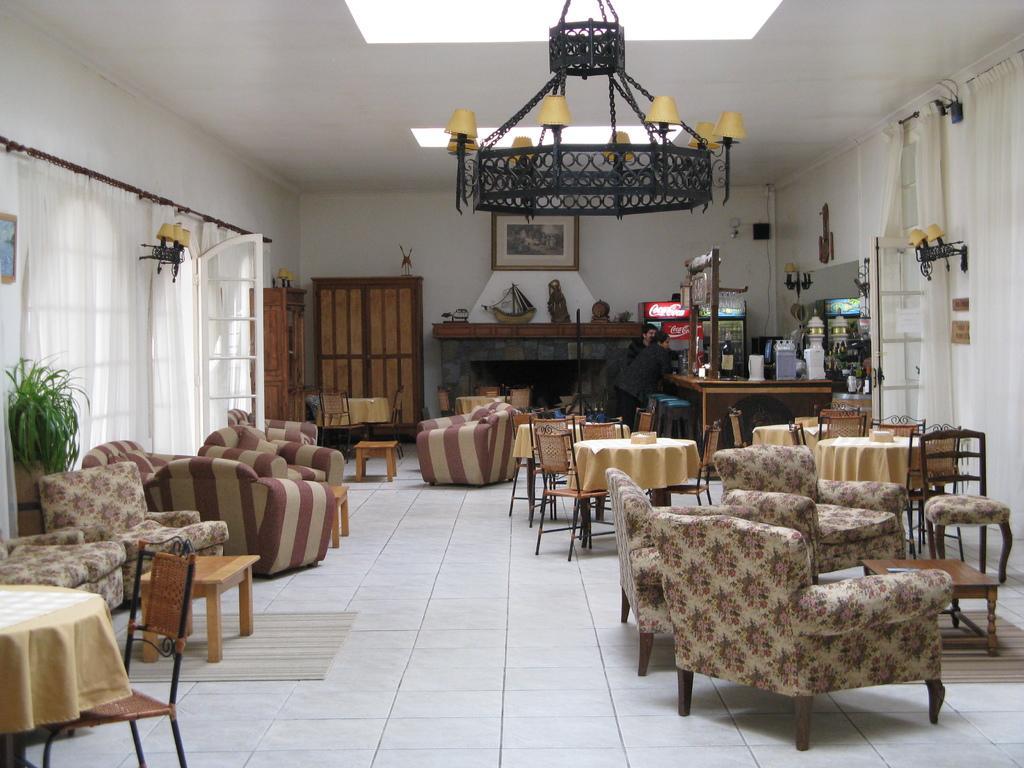Please provide a concise description of this image. In this image I can see number of couches,few chairs and few tables. I can also see few lamps and curtains. 